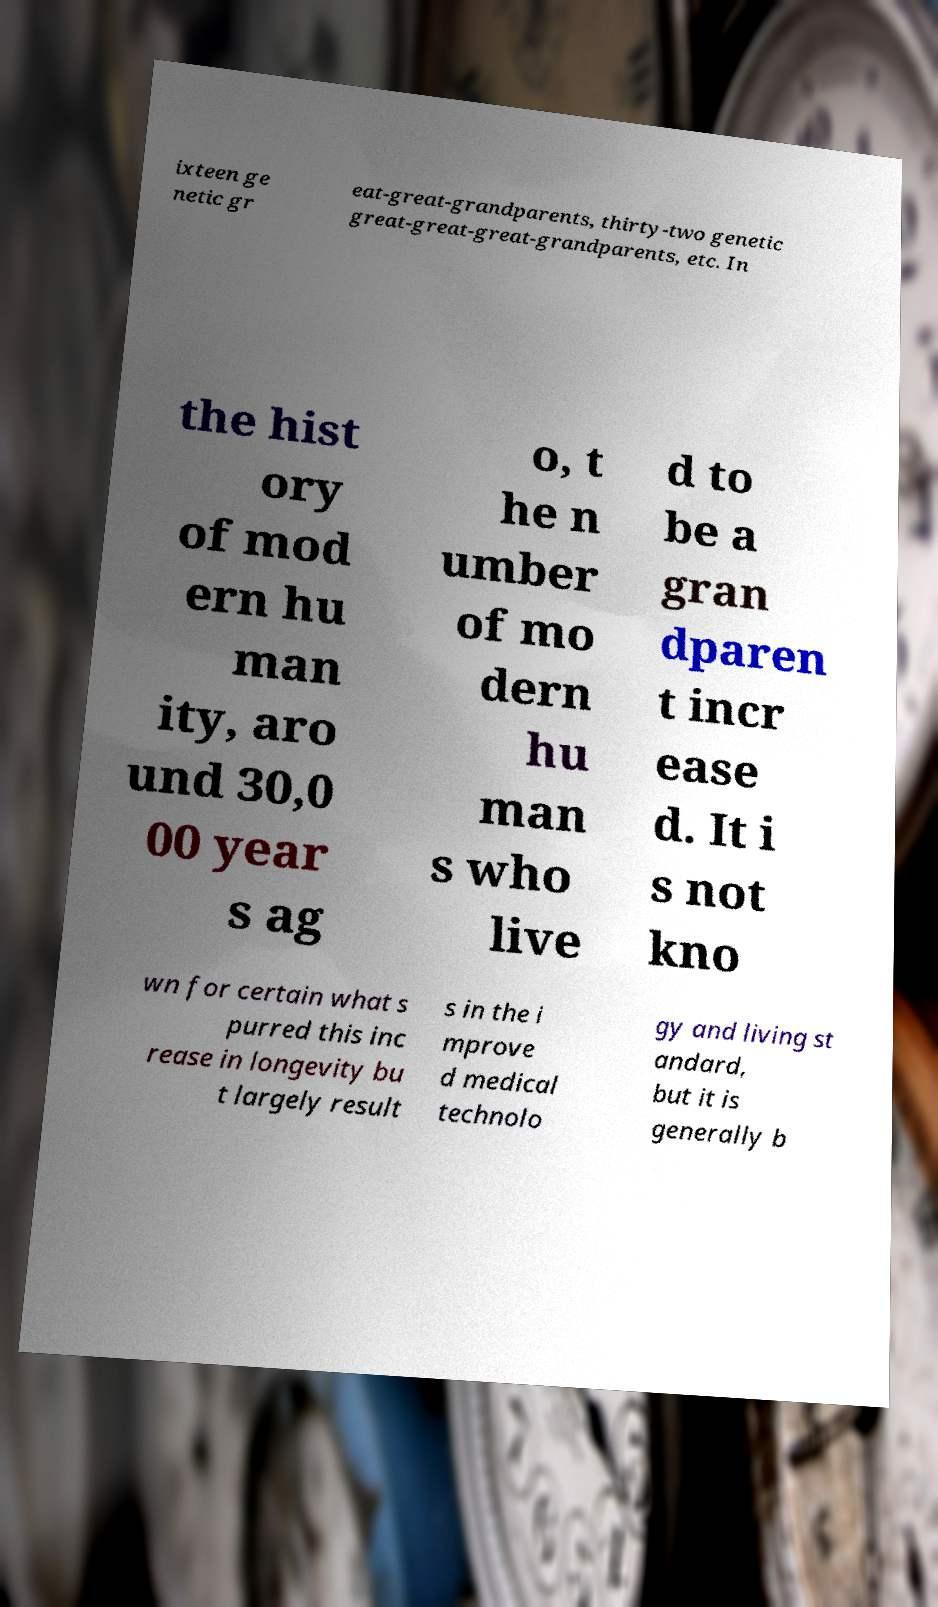Can you read and provide the text displayed in the image?This photo seems to have some interesting text. Can you extract and type it out for me? ixteen ge netic gr eat-great-grandparents, thirty-two genetic great-great-great-grandparents, etc. In the hist ory of mod ern hu man ity, aro und 30,0 00 year s ag o, t he n umber of mo dern hu man s who live d to be a gran dparen t incr ease d. It i s not kno wn for certain what s purred this inc rease in longevity bu t largely result s in the i mprove d medical technolo gy and living st andard, but it is generally b 